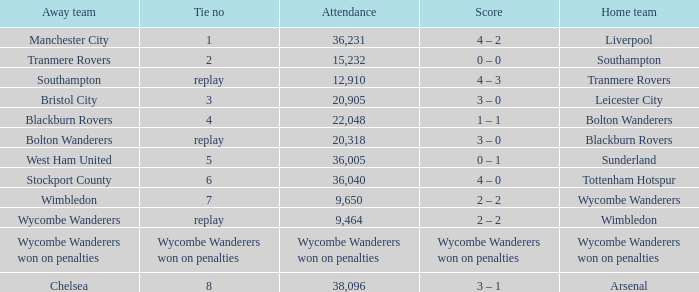What was the score for the match where the home team was Leicester City? 3 – 0. 